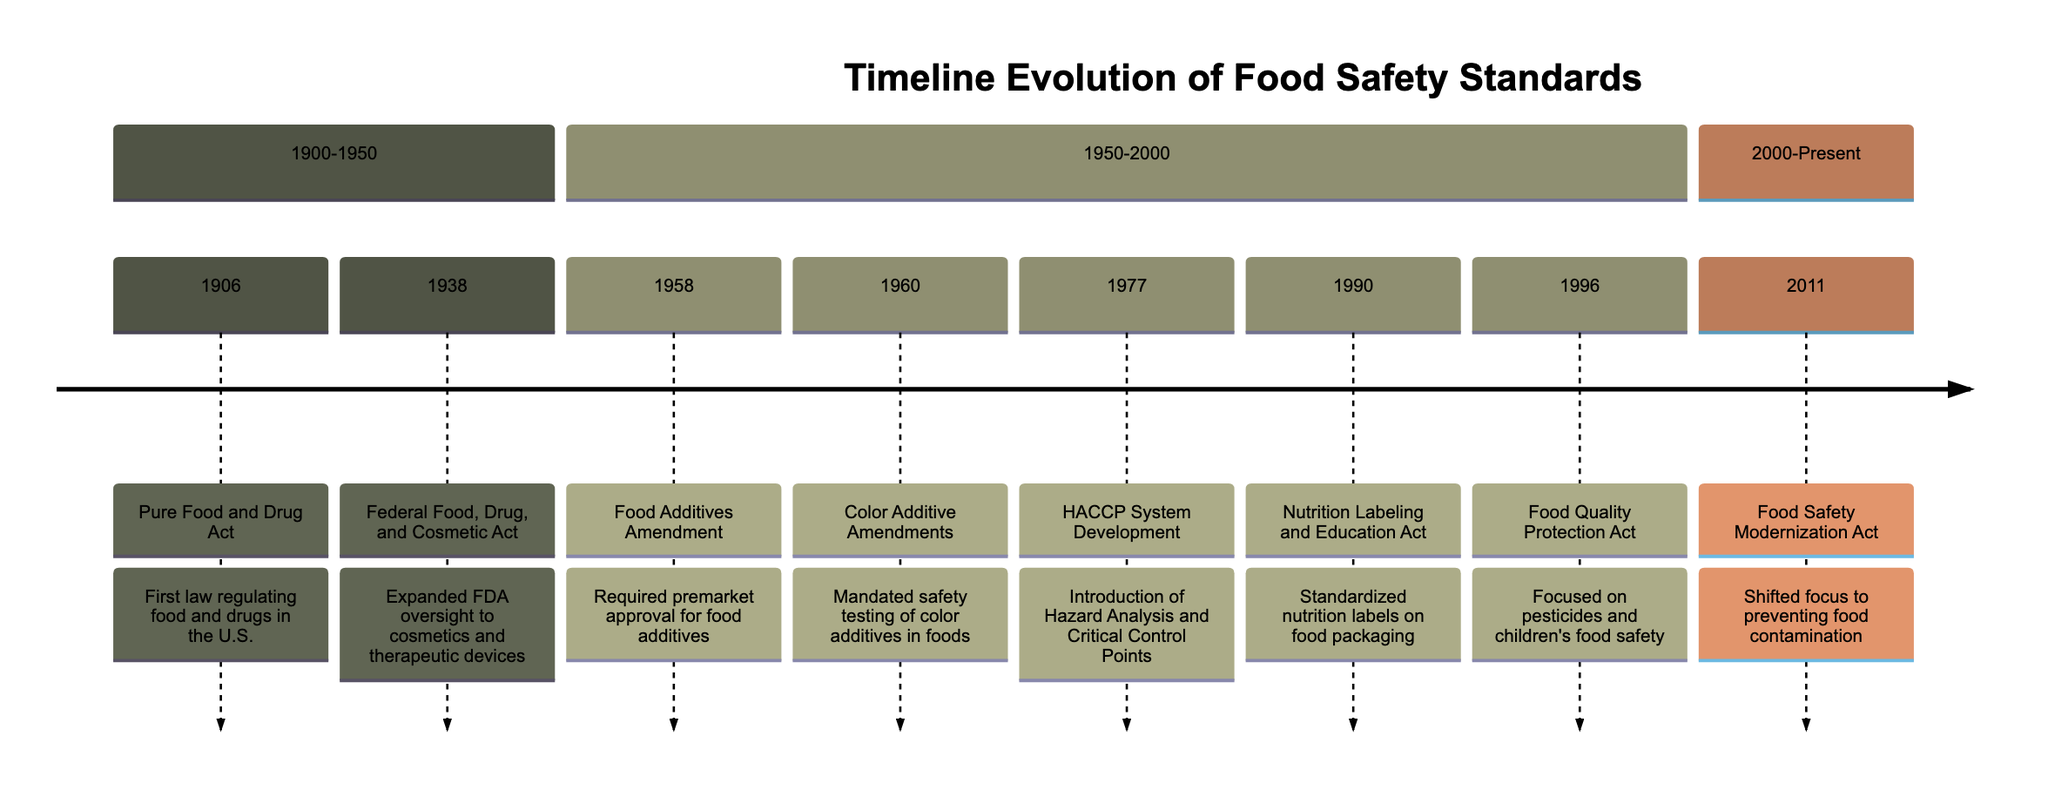What year was the Pure Food and Drug Act established? The diagram indicates that the Pure Food and Drug Act was established in the year 1906. It is the first node listed under the section 1900-1950.
Answer: 1906 What major food safety milestone occurred in 1990? The Nutrition Labeling and Education Act is the milestone noted in the timeline for the year 1990, which is directly visible in the 1950-2000 section.
Answer: Nutrition Labeling and Education Act How many significant food safety standards were established between 1950 and 2000? By counting the listed milestones in the 1950-2000 section, there are five significant standards, including the Food Additives Amendment, Color Additive Amendments, HACCP System Development, Nutrition Labeling and Education Act, and Food Quality Protection Act.
Answer: 5 What law shifted the focus to preventing food contamination? In the timeline, the Food Safety Modernization Act, listed under the 2000-Present section, is identified as the law that shifted focus to preventing food contamination.
Answer: Food Safety Modernization Act Which amendment mandated safety testing of color additives in foods? The Color Additive Amendments of 1960 mandated the safety testing of color additives, as indicated in the timeline under the section 1950-2000.
Answer: Color Additive Amendments What year did the Federal Food, Drug, and Cosmetic Act come into effect? The diagram states that the Federal Food, Drug, and Cosmetic Act came into effect in 1938 under the 1900-1950 section.
Answer: 1938 Which act focused on pesticides and children's food safety? The Food Quality Protection Act is the act that focused on pesticides and children's food safety, which is noted in the timeline for the year 1996.
Answer: Food Quality Protection Act What is the first regulatory milestone highlighted in the timeline? The first regulatory milestone highlighted in the timeline is the Pure Food and Drug Act, established in 1906, as it is the first entry in the diagram.
Answer: Pure Food and Drug Act How many milestones are listed under the section 2000-Present? There is only one milestone, the Food Safety Modernization Act, listed under the 2000-Present section of the diagram.
Answer: 1 